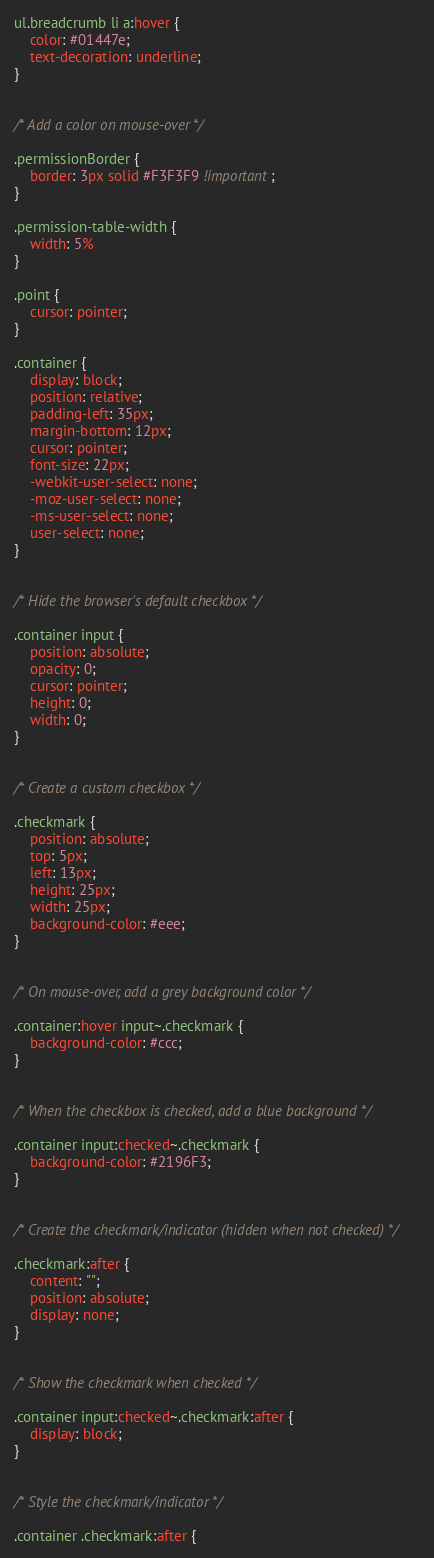Convert code to text. <code><loc_0><loc_0><loc_500><loc_500><_CSS_>ul.breadcrumb li a:hover {
    color: #01447e;
    text-decoration: underline;
}


/* Add a color on mouse-over */

.permissionBorder {
    border: 3px solid #F3F3F9 !important;
}

.permission-table-width {
    width: 5%
}

.point {
    cursor: pointer;
}

.container {
    display: block;
    position: relative;
    padding-left: 35px;
    margin-bottom: 12px;
    cursor: pointer;
    font-size: 22px;
    -webkit-user-select: none;
    -moz-user-select: none;
    -ms-user-select: none;
    user-select: none;
}


/* Hide the browser's default checkbox */

.container input {
    position: absolute;
    opacity: 0;
    cursor: pointer;
    height: 0;
    width: 0;
}


/* Create a custom checkbox */

.checkmark {
    position: absolute;
    top: 5px;
    left: 13px;
    height: 25px;
    width: 25px;
    background-color: #eee;
}


/* On mouse-over, add a grey background color */

.container:hover input~.checkmark {
    background-color: #ccc;
}


/* When the checkbox is checked, add a blue background */

.container input:checked~.checkmark {
    background-color: #2196F3;
}


/* Create the checkmark/indicator (hidden when not checked) */

.checkmark:after {
    content: "";
    position: absolute;
    display: none;
}


/* Show the checkmark when checked */

.container input:checked~.checkmark:after {
    display: block;
}


/* Style the checkmark/indicator */

.container .checkmark:after {</code> 